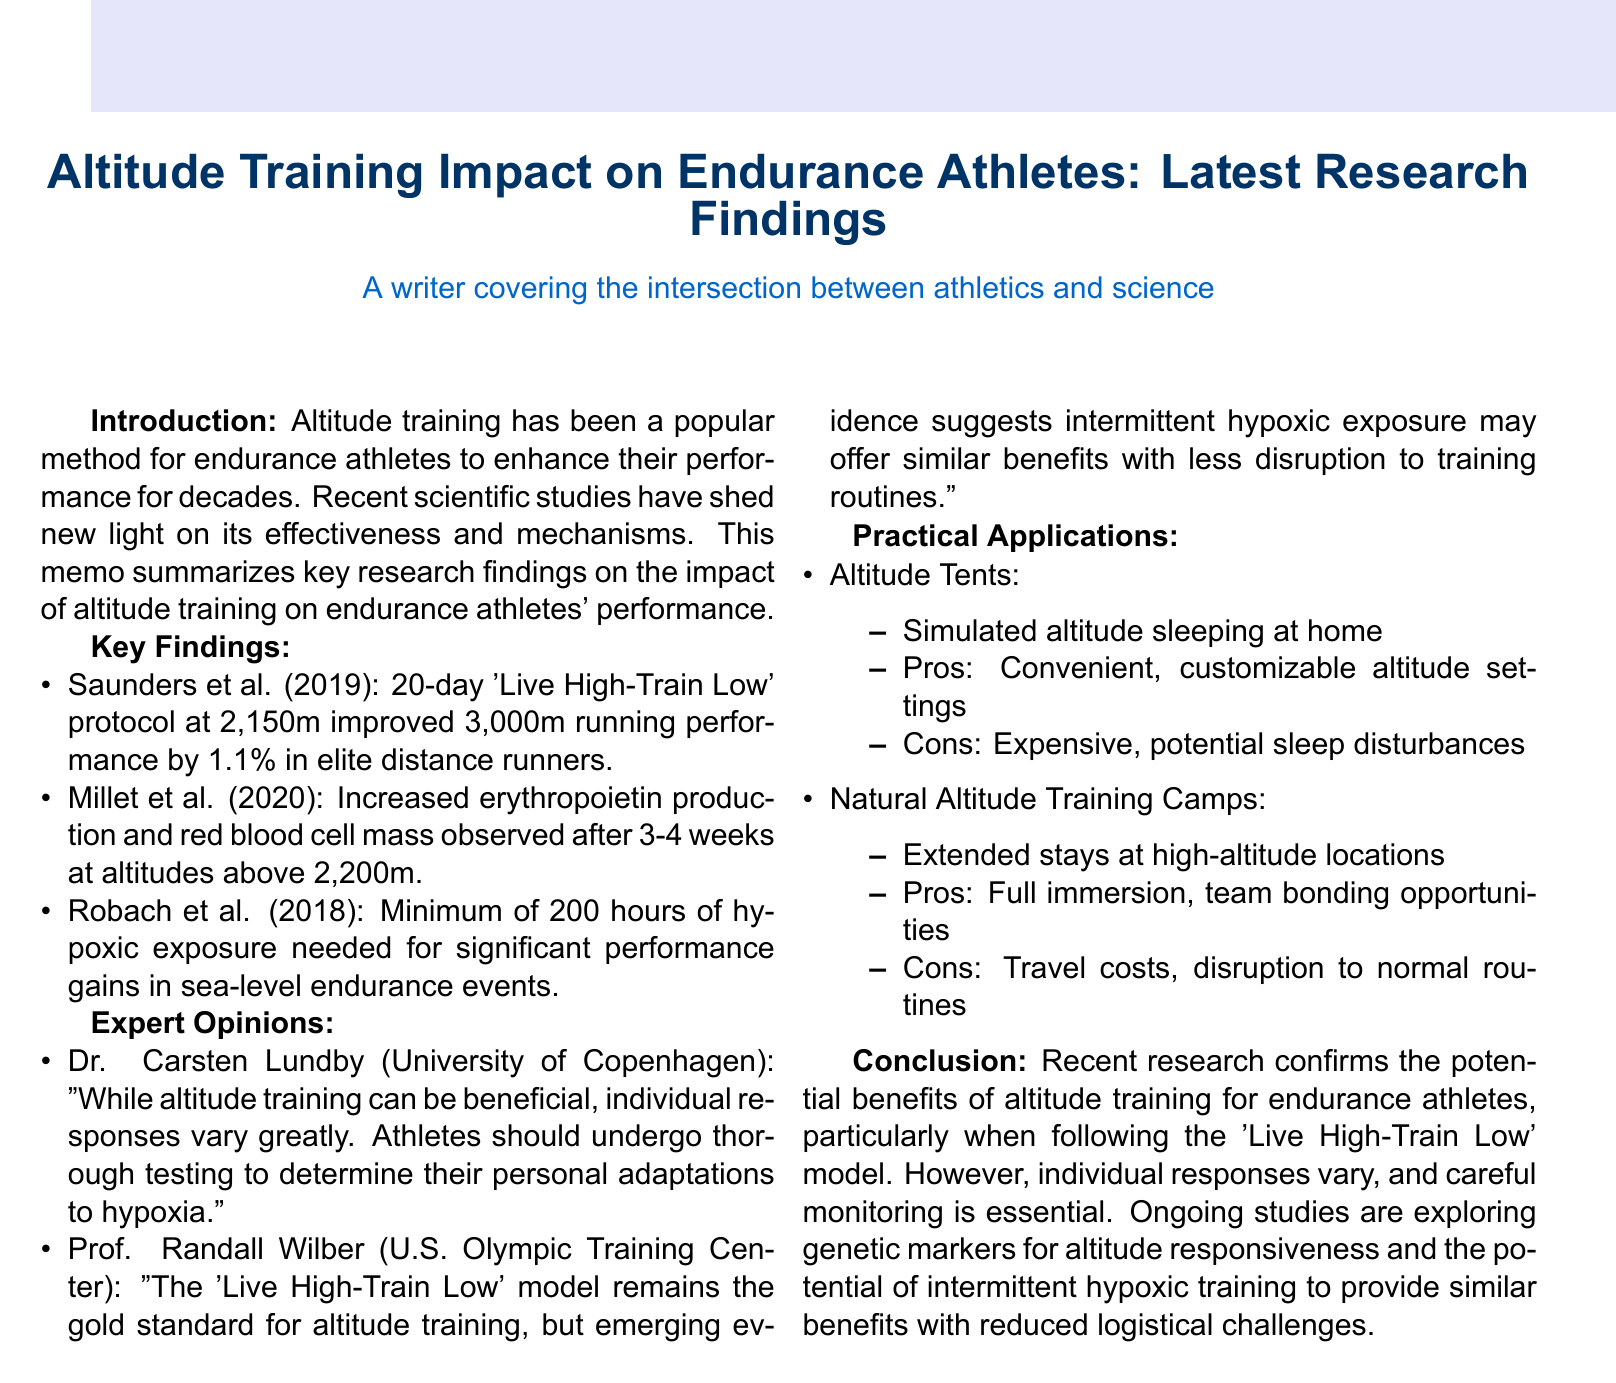what is the title of the memo? The title reflects the main topic discussed in the memo, which is the impact of altitude training on endurance athletes, specifically highlighting recent research findings.
Answer: Altitude Training Impact on Endurance Athletes: Latest Research Findings who conducted the study in the Journal of Applied Physiology? The study that is referenced for the 'Live High-Train Low' protocol was done by Saunders et al., as noted in the key findings section.
Answer: Saunders et al how much did the 'Live High-Train Low' protocol improve running performance? The specific percentage improvement attributed to the altitude training protocol is highlighted in the findings of the research study.
Answer: 1.1% how long should hypoxic exposure last for significant performance gains? The document provides a guideline on the minimum hours of hypoxic exposure crucial for achieving performance improvements.
Answer: 200 hours what is a practical application of altitude training that allows athletes to sleep at home? This application is mentioned in the practical applications section where convenience is a key factor.
Answer: Altitude Tents who is affiliated with the University of Copenhagen? The memo lists experts sharing their opinions, one of whom is associated with this academic institution.
Answer: Dr. Carsten Lundby what is one con of using altitude tents? The drawbacks of altitude tents are discussed in relation to their impact on the athlete's experience and practicality.
Answer: Potential sleep disturbances what does ongoing research explore regarding altitude responsiveness? The memo mentions this area of investigation suggesting it could reveal more about how athletes adapt to altitude training.
Answer: Genetic markers 